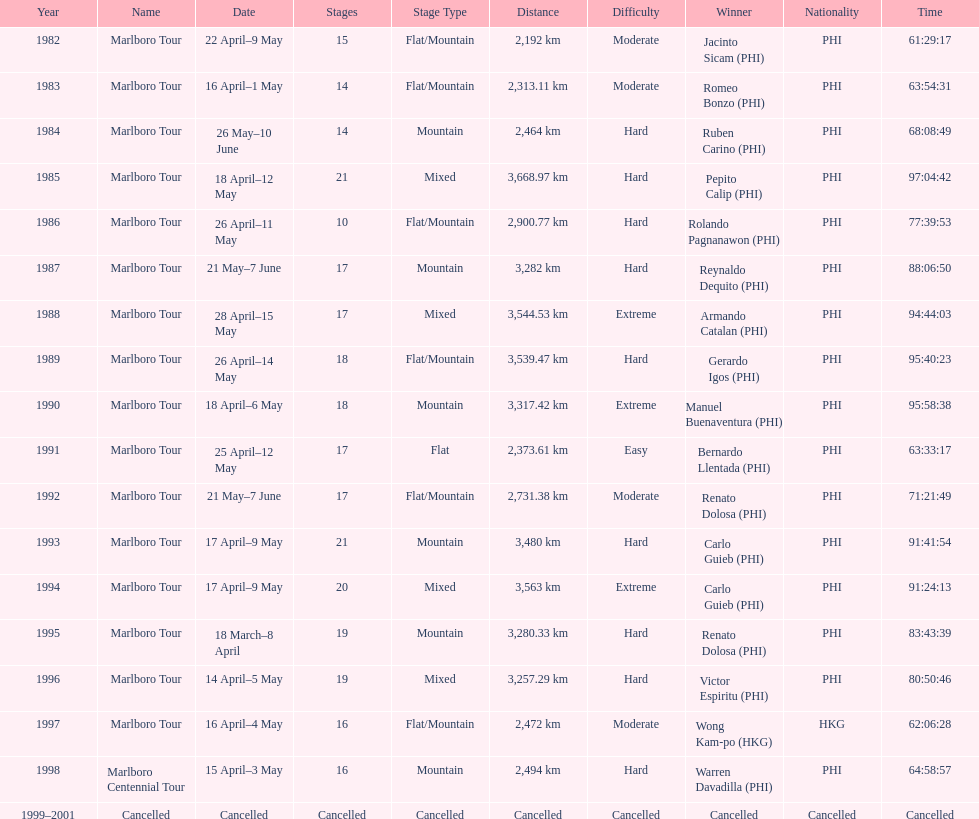Can you give me this table as a dict? {'header': ['Year', 'Name', 'Date', 'Stages', 'Stage Type', 'Distance', 'Difficulty', 'Winner', 'Nationality', 'Time'], 'rows': [['1982', 'Marlboro Tour', '22 April–9 May', '15', 'Flat/Mountain', '2,192\xa0km', 'Moderate', 'Jacinto Sicam\xa0(PHI)', 'PHI', '61:29:17'], ['1983', 'Marlboro Tour', '16 April–1 May', '14', 'Flat/Mountain', '2,313.11\xa0km', 'Moderate', 'Romeo Bonzo\xa0(PHI)', 'PHI', '63:54:31'], ['1984', 'Marlboro Tour', '26 May–10 June', '14', 'Mountain', '2,464\xa0km', 'Hard', 'Ruben Carino\xa0(PHI)', 'PHI', '68:08:49'], ['1985', 'Marlboro Tour', '18 April–12 May', '21', 'Mixed', '3,668.97\xa0km', 'Hard', 'Pepito Calip\xa0(PHI)', 'PHI', '97:04:42'], ['1986', 'Marlboro Tour', '26 April–11 May', '10', 'Flat/Mountain', '2,900.77\xa0km', 'Hard', 'Rolando Pagnanawon\xa0(PHI)', 'PHI', '77:39:53'], ['1987', 'Marlboro Tour', '21 May–7 June', '17', 'Mountain', '3,282\xa0km', 'Hard', 'Reynaldo Dequito\xa0(PHI)', 'PHI', '88:06:50'], ['1988', 'Marlboro Tour', '28 April–15 May', '17', 'Mixed', '3,544.53\xa0km', 'Extreme', 'Armando Catalan\xa0(PHI)', 'PHI', '94:44:03'], ['1989', 'Marlboro Tour', '26 April–14 May', '18', 'Flat/Mountain', '3,539.47\xa0km', 'Hard', 'Gerardo Igos\xa0(PHI)', 'PHI', '95:40:23'], ['1990', 'Marlboro Tour', '18 April–6 May', '18', 'Mountain', '3,317.42\xa0km', 'Extreme', 'Manuel Buenaventura\xa0(PHI)', 'PHI', '95:58:38'], ['1991', 'Marlboro Tour', '25 April–12 May', '17', 'Flat', '2,373.61\xa0km', 'Easy', 'Bernardo Llentada\xa0(PHI)', 'PHI', '63:33:17'], ['1992', 'Marlboro Tour', '21 May–7 June', '17', 'Flat/Mountain', '2,731.38\xa0km', 'Moderate', 'Renato Dolosa\xa0(PHI)', 'PHI', '71:21:49'], ['1993', 'Marlboro Tour', '17 April–9 May', '21', 'Mountain', '3,480\xa0km', 'Hard', 'Carlo Guieb\xa0(PHI)', 'PHI', '91:41:54'], ['1994', 'Marlboro Tour', '17 April–9 May', '20', 'Mixed', '3,563\xa0km', 'Extreme', 'Carlo Guieb\xa0(PHI)', 'PHI', '91:24:13'], ['1995', 'Marlboro Tour', '18 March–8 April', '19', 'Mountain', '3,280.33\xa0km', 'Hard', 'Renato Dolosa\xa0(PHI)', 'PHI', '83:43:39'], ['1996', 'Marlboro Tour', '14 April–5 May', '19', 'Mixed', '3,257.29\xa0km', 'Hard', 'Victor Espiritu\xa0(PHI)', 'PHI', '80:50:46'], ['1997', 'Marlboro Tour', '16 April–4 May', '16', 'Flat/Mountain', '2,472\xa0km', 'Moderate', 'Wong Kam-po\xa0(HKG)', 'HKG', '62:06:28'], ['1998', 'Marlboro Centennial Tour', '15 April–3 May', '16', 'Mountain', '2,494\xa0km', 'Hard', 'Warren Davadilla\xa0(PHI)', 'PHI', '64:58:57'], ['1999–2001', 'Cancelled', 'Cancelled', 'Cancelled', 'Cancelled', 'Cancelled', 'Cancelled', 'Cancelled', 'Cancelled', 'Cancelled']]} Who won the most marlboro tours? Carlo Guieb. 